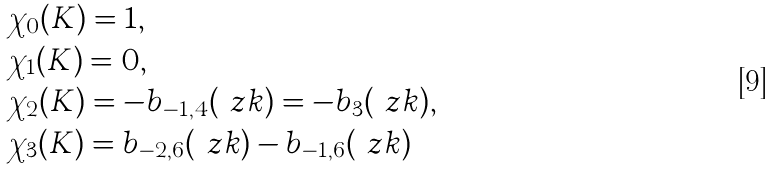<formula> <loc_0><loc_0><loc_500><loc_500>& \chi _ { 0 } ( K ) = 1 , \\ & \chi _ { 1 } ( K ) = 0 , \\ & \chi _ { 2 } ( K ) = - b _ { - 1 , 4 } ( \ z k ) = - b _ { 3 } ( \ z k ) , \\ & \chi _ { 3 } ( K ) = b _ { - 2 , 6 } ( \ z k ) - b _ { - 1 , 6 } ( \ z k )</formula> 